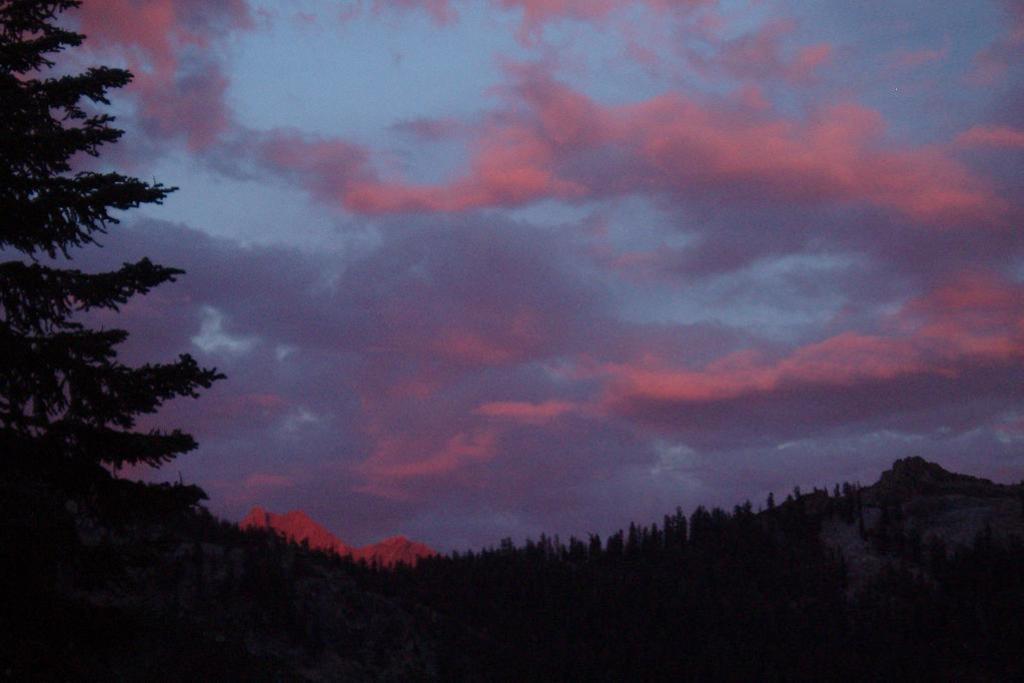Describe this image in one or two sentences. In this picture we can see a few trees from left to right. Sky is cloudy. 